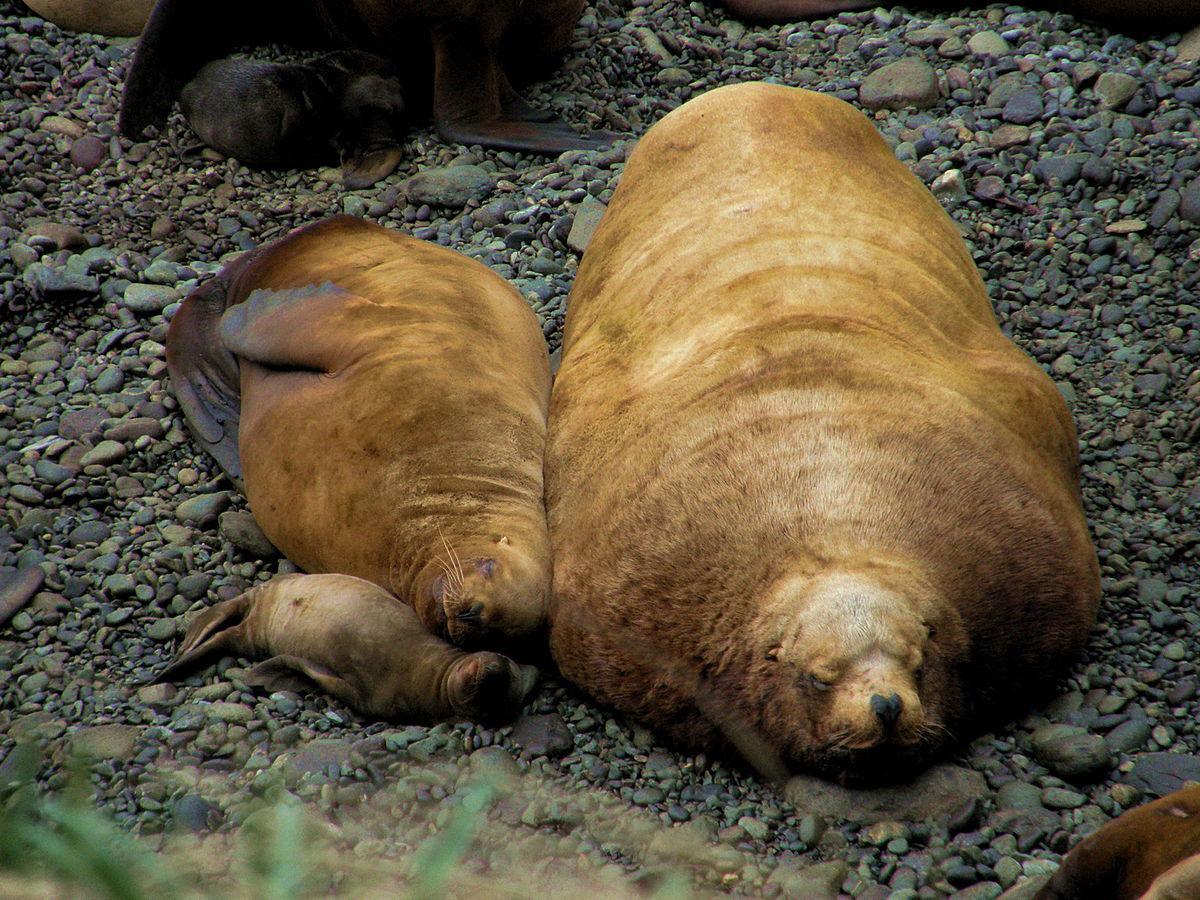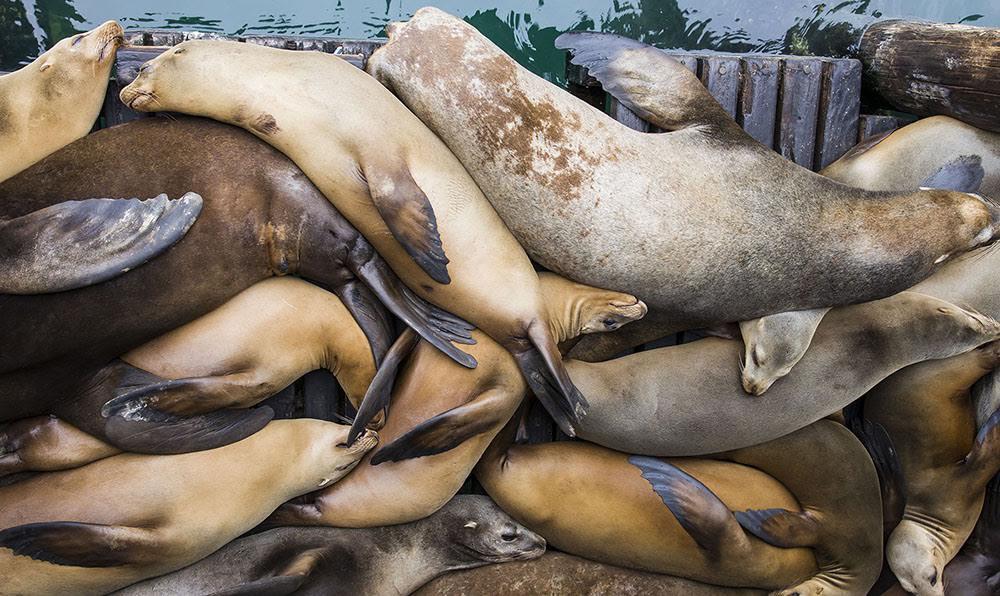The first image is the image on the left, the second image is the image on the right. Evaluate the accuracy of this statement regarding the images: "The left hand image shows less than four seals laying on the ground.". Is it true? Answer yes or no. Yes. The first image is the image on the left, the second image is the image on the right. Considering the images on both sides, is "One image shows no more than three seals in the foreground, and the other shows seals piled on top of each other." valid? Answer yes or no. Yes. 